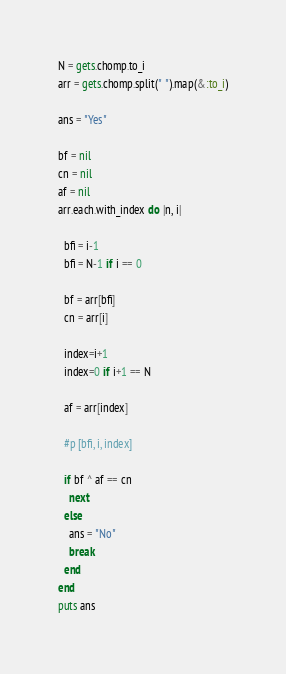Convert code to text. <code><loc_0><loc_0><loc_500><loc_500><_Ruby_>N = gets.chomp.to_i
arr = gets.chomp.split(" ").map(&:to_i)

ans = "Yes"

bf = nil
cn = nil
af = nil
arr.each.with_index do |n, i|

  bfi = i-1
  bfi = N-1 if i == 0

  bf = arr[bfi]
  cn = arr[i]
  
  index=i+1
  index=0 if i+1 == N

  af = arr[index]
  
  #p [bfi, i, index]
  
  if bf ^ af == cn
    next
  else
    ans = "No"
    break
  end
end
puts ans</code> 